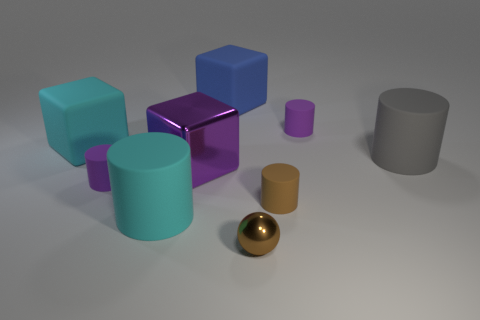Subtract all large gray cylinders. How many cylinders are left? 4 Subtract all gray cylinders. How many cylinders are left? 4 Subtract all red cylinders. Subtract all green blocks. How many cylinders are left? 5 Add 1 large cyan cylinders. How many objects exist? 10 Subtract all cubes. How many objects are left? 6 Subtract 0 yellow cylinders. How many objects are left? 9 Subtract all large cyan rubber cylinders. Subtract all cyan cubes. How many objects are left? 7 Add 9 big cyan rubber blocks. How many big cyan rubber blocks are left? 10 Add 3 gray rubber objects. How many gray rubber objects exist? 4 